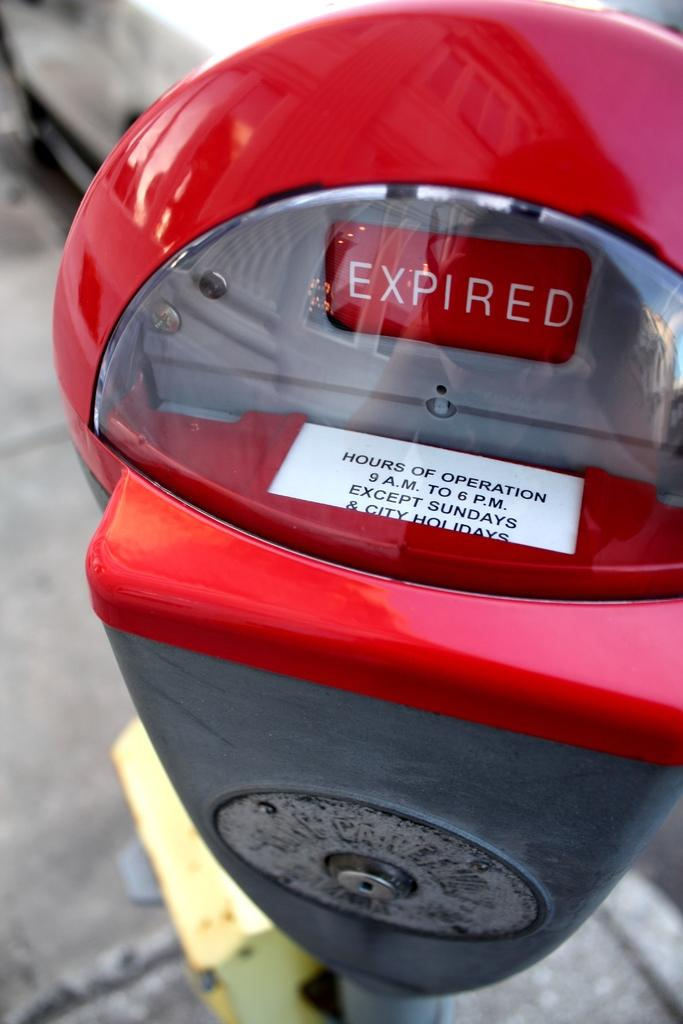<image>
Present a compact description of the photo's key features. a red and silver parking meter is expired 